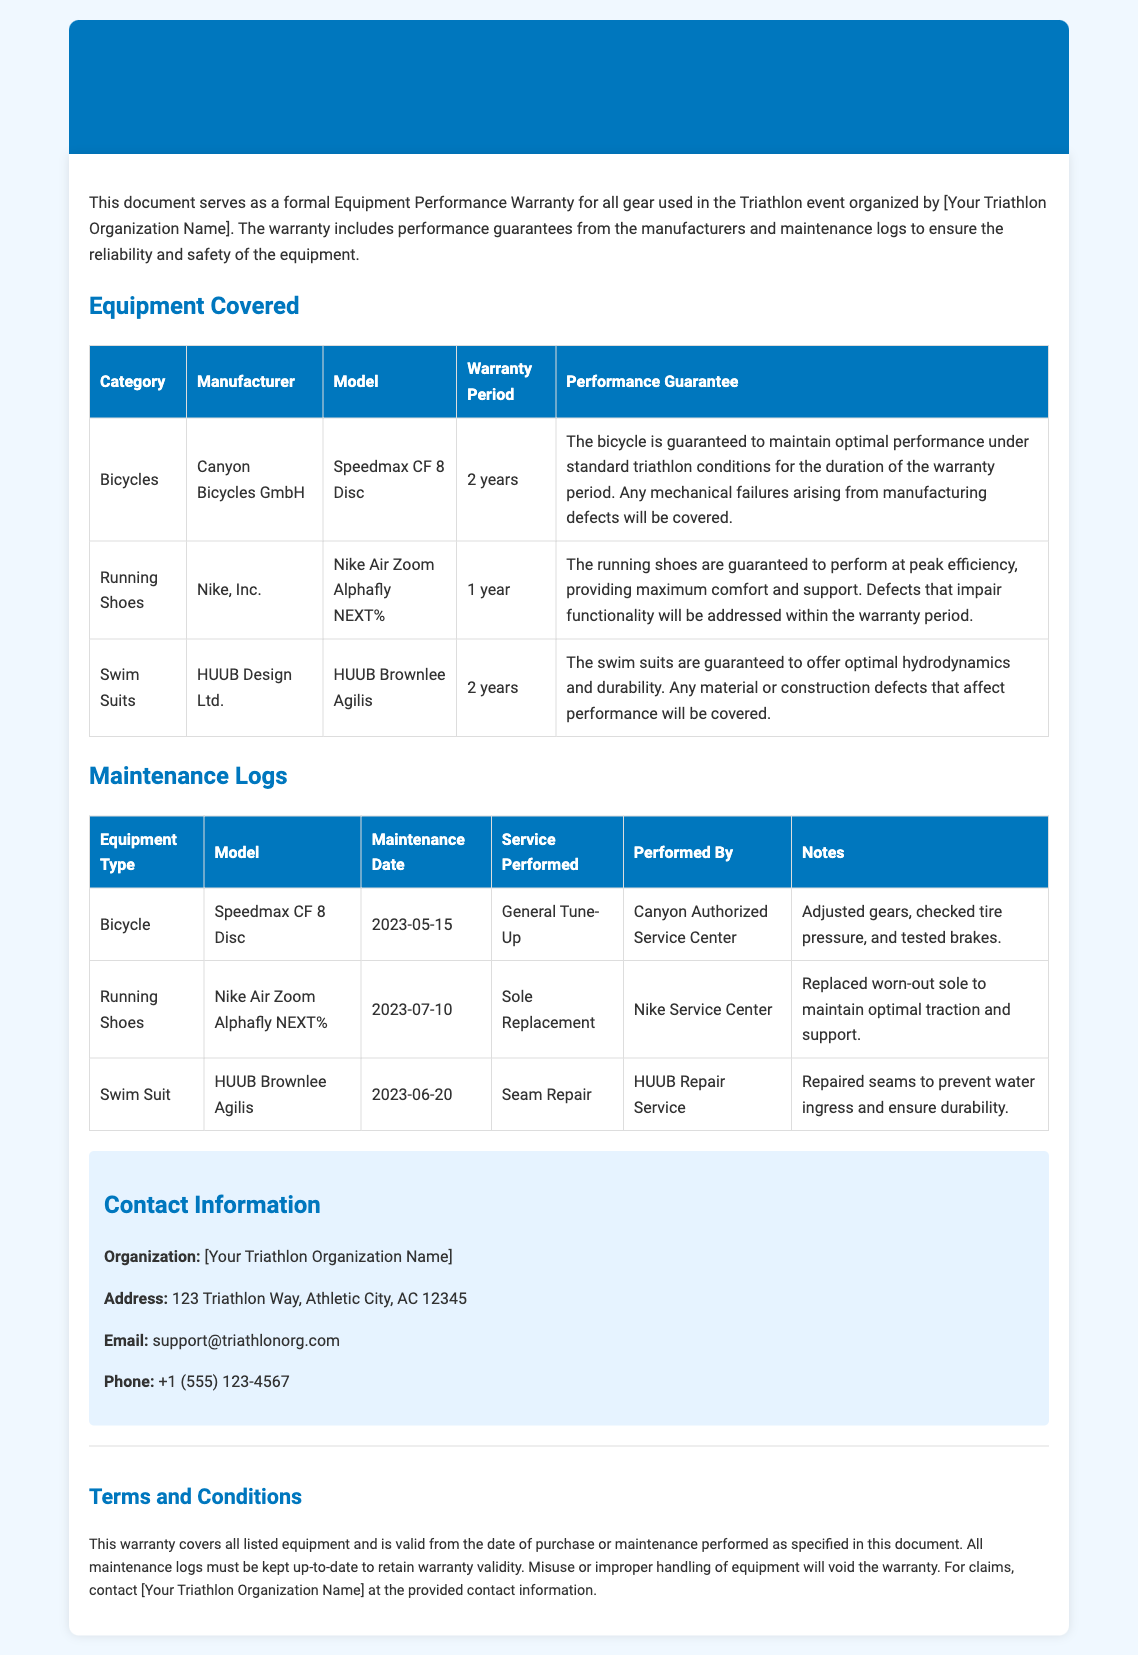What is the warranty period for bicycles? The warranty period for bicycles is stated in the document as 2 years.
Answer: 2 years Who is the manufacturer of the running shoes? The running shoes listed in the document are manufactured by Nike, Inc.
Answer: Nike, Inc What maintenance was performed on the swim suit? The maintenance performed on the swim suit was a seam repair, as detailed in the maintenance logs.
Answer: Seam Repair When was the general tune-up for the bicycle done? The date of the general tune-up for the bicycle can be found in the maintenance logs, which states it was performed on 2023-05-15.
Answer: 2023-05-15 What type of warranty does the document represent? The document represents an Equipment Performance Warranty for gear used in the triathlon event.
Answer: Equipment Performance Warranty How long is the warranty for running shoes? The duration of the warranty for running shoes, as mentioned in the document, is 1 year.
Answer: 1 year Which organization can be contacted for warranty claims? The organization to contact for warranty claims is provided in the contact information section of the document.
Answer: [Your Triathlon Organization Name] What service was performed on the running shoes? The service that was performed on the running shoes is noted in the maintenance logs as sole replacement.
Answer: Sole Replacement What is required to retain warranty validity? The document specifies that all maintenance logs must be kept up-to-date to retain warranty validity.
Answer: Up-to-date maintenance logs 